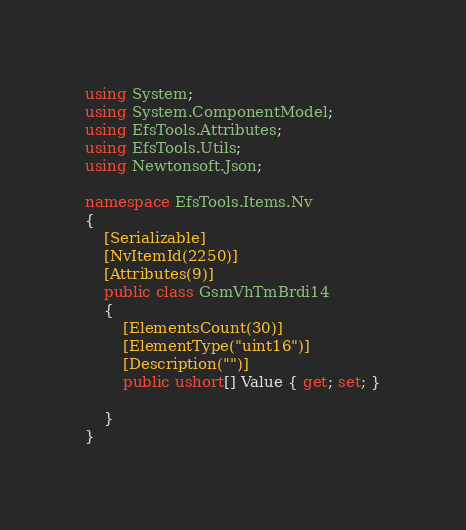Convert code to text. <code><loc_0><loc_0><loc_500><loc_500><_C#_>using System;
using System.ComponentModel;
using EfsTools.Attributes;
using EfsTools.Utils;
using Newtonsoft.Json;

namespace EfsTools.Items.Nv
{
    [Serializable]
    [NvItemId(2250)]
    [Attributes(9)]
    public class GsmVhTmBrdi14
    {
        [ElementsCount(30)]
        [ElementType("uint16")]
        [Description("")]
        public ushort[] Value { get; set; }
        
    }
}
</code> 